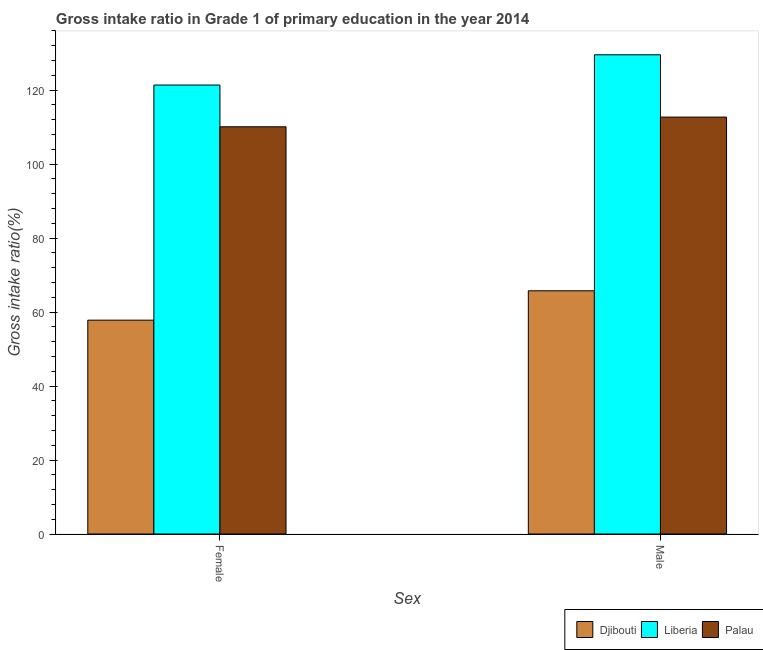How many different coloured bars are there?
Keep it short and to the point. 3. Are the number of bars on each tick of the X-axis equal?
Your answer should be compact. Yes. How many bars are there on the 2nd tick from the left?
Offer a very short reply. 3. What is the label of the 2nd group of bars from the left?
Ensure brevity in your answer.  Male. What is the gross intake ratio(male) in Palau?
Your response must be concise. 112.71. Across all countries, what is the maximum gross intake ratio(female)?
Ensure brevity in your answer.  121.38. Across all countries, what is the minimum gross intake ratio(male)?
Offer a terse response. 65.75. In which country was the gross intake ratio(female) maximum?
Provide a succinct answer. Liberia. In which country was the gross intake ratio(female) minimum?
Your answer should be compact. Djibouti. What is the total gross intake ratio(female) in the graph?
Offer a terse response. 289.28. What is the difference between the gross intake ratio(male) in Palau and that in Djibouti?
Your answer should be very brief. 46.96. What is the difference between the gross intake ratio(male) in Liberia and the gross intake ratio(female) in Palau?
Provide a short and direct response. 19.47. What is the average gross intake ratio(female) per country?
Your response must be concise. 96.43. What is the difference between the gross intake ratio(female) and gross intake ratio(male) in Liberia?
Provide a succinct answer. -8.18. What is the ratio of the gross intake ratio(female) in Djibouti to that in Liberia?
Your response must be concise. 0.48. Is the gross intake ratio(male) in Liberia less than that in Palau?
Provide a short and direct response. No. What does the 3rd bar from the left in Male represents?
Provide a succinct answer. Palau. What does the 3rd bar from the right in Female represents?
Provide a succinct answer. Djibouti. How many bars are there?
Your answer should be compact. 6. What is the difference between two consecutive major ticks on the Y-axis?
Your answer should be very brief. 20. Are the values on the major ticks of Y-axis written in scientific E-notation?
Provide a short and direct response. No. Does the graph contain grids?
Give a very brief answer. No. How are the legend labels stacked?
Your response must be concise. Horizontal. What is the title of the graph?
Keep it short and to the point. Gross intake ratio in Grade 1 of primary education in the year 2014. Does "American Samoa" appear as one of the legend labels in the graph?
Your response must be concise. No. What is the label or title of the X-axis?
Your response must be concise. Sex. What is the label or title of the Y-axis?
Your answer should be compact. Gross intake ratio(%). What is the Gross intake ratio(%) of Djibouti in Female?
Provide a short and direct response. 57.81. What is the Gross intake ratio(%) in Liberia in Female?
Your response must be concise. 121.38. What is the Gross intake ratio(%) of Palau in Female?
Make the answer very short. 110.09. What is the Gross intake ratio(%) of Djibouti in Male?
Your response must be concise. 65.75. What is the Gross intake ratio(%) in Liberia in Male?
Give a very brief answer. 129.56. What is the Gross intake ratio(%) of Palau in Male?
Your response must be concise. 112.71. Across all Sex, what is the maximum Gross intake ratio(%) of Djibouti?
Offer a terse response. 65.75. Across all Sex, what is the maximum Gross intake ratio(%) in Liberia?
Your response must be concise. 129.56. Across all Sex, what is the maximum Gross intake ratio(%) of Palau?
Ensure brevity in your answer.  112.71. Across all Sex, what is the minimum Gross intake ratio(%) of Djibouti?
Provide a short and direct response. 57.81. Across all Sex, what is the minimum Gross intake ratio(%) in Liberia?
Your answer should be compact. 121.38. Across all Sex, what is the minimum Gross intake ratio(%) in Palau?
Your response must be concise. 110.09. What is the total Gross intake ratio(%) of Djibouti in the graph?
Offer a terse response. 123.56. What is the total Gross intake ratio(%) in Liberia in the graph?
Give a very brief answer. 250.94. What is the total Gross intake ratio(%) of Palau in the graph?
Ensure brevity in your answer.  222.8. What is the difference between the Gross intake ratio(%) of Djibouti in Female and that in Male?
Keep it short and to the point. -7.94. What is the difference between the Gross intake ratio(%) of Liberia in Female and that in Male?
Keep it short and to the point. -8.18. What is the difference between the Gross intake ratio(%) in Palau in Female and that in Male?
Your response must be concise. -2.62. What is the difference between the Gross intake ratio(%) in Djibouti in Female and the Gross intake ratio(%) in Liberia in Male?
Give a very brief answer. -71.75. What is the difference between the Gross intake ratio(%) of Djibouti in Female and the Gross intake ratio(%) of Palau in Male?
Provide a succinct answer. -54.9. What is the difference between the Gross intake ratio(%) of Liberia in Female and the Gross intake ratio(%) of Palau in Male?
Offer a terse response. 8.67. What is the average Gross intake ratio(%) in Djibouti per Sex?
Your response must be concise. 61.78. What is the average Gross intake ratio(%) of Liberia per Sex?
Offer a terse response. 125.47. What is the average Gross intake ratio(%) in Palau per Sex?
Give a very brief answer. 111.4. What is the difference between the Gross intake ratio(%) in Djibouti and Gross intake ratio(%) in Liberia in Female?
Keep it short and to the point. -63.57. What is the difference between the Gross intake ratio(%) of Djibouti and Gross intake ratio(%) of Palau in Female?
Your answer should be very brief. -52.28. What is the difference between the Gross intake ratio(%) of Liberia and Gross intake ratio(%) of Palau in Female?
Offer a terse response. 11.29. What is the difference between the Gross intake ratio(%) of Djibouti and Gross intake ratio(%) of Liberia in Male?
Make the answer very short. -63.81. What is the difference between the Gross intake ratio(%) of Djibouti and Gross intake ratio(%) of Palau in Male?
Give a very brief answer. -46.96. What is the difference between the Gross intake ratio(%) of Liberia and Gross intake ratio(%) of Palau in Male?
Your answer should be very brief. 16.85. What is the ratio of the Gross intake ratio(%) in Djibouti in Female to that in Male?
Keep it short and to the point. 0.88. What is the ratio of the Gross intake ratio(%) of Liberia in Female to that in Male?
Your response must be concise. 0.94. What is the ratio of the Gross intake ratio(%) of Palau in Female to that in Male?
Ensure brevity in your answer.  0.98. What is the difference between the highest and the second highest Gross intake ratio(%) in Djibouti?
Your answer should be compact. 7.94. What is the difference between the highest and the second highest Gross intake ratio(%) of Liberia?
Ensure brevity in your answer.  8.18. What is the difference between the highest and the second highest Gross intake ratio(%) of Palau?
Offer a very short reply. 2.62. What is the difference between the highest and the lowest Gross intake ratio(%) in Djibouti?
Provide a short and direct response. 7.94. What is the difference between the highest and the lowest Gross intake ratio(%) of Liberia?
Your answer should be very brief. 8.18. What is the difference between the highest and the lowest Gross intake ratio(%) in Palau?
Make the answer very short. 2.62. 